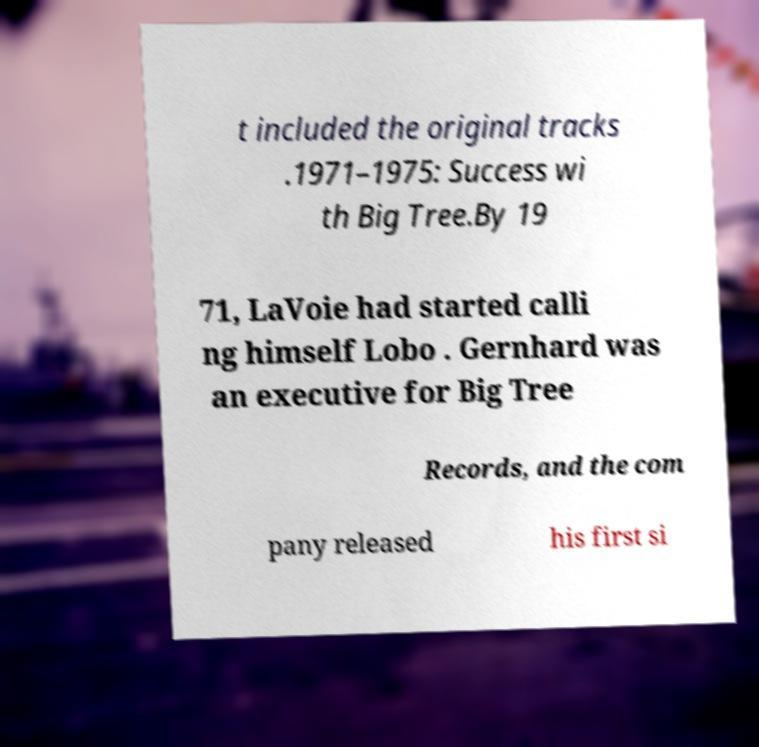I need the written content from this picture converted into text. Can you do that? t included the original tracks .1971–1975: Success wi th Big Tree.By 19 71, LaVoie had started calli ng himself Lobo . Gernhard was an executive for Big Tree Records, and the com pany released his first si 